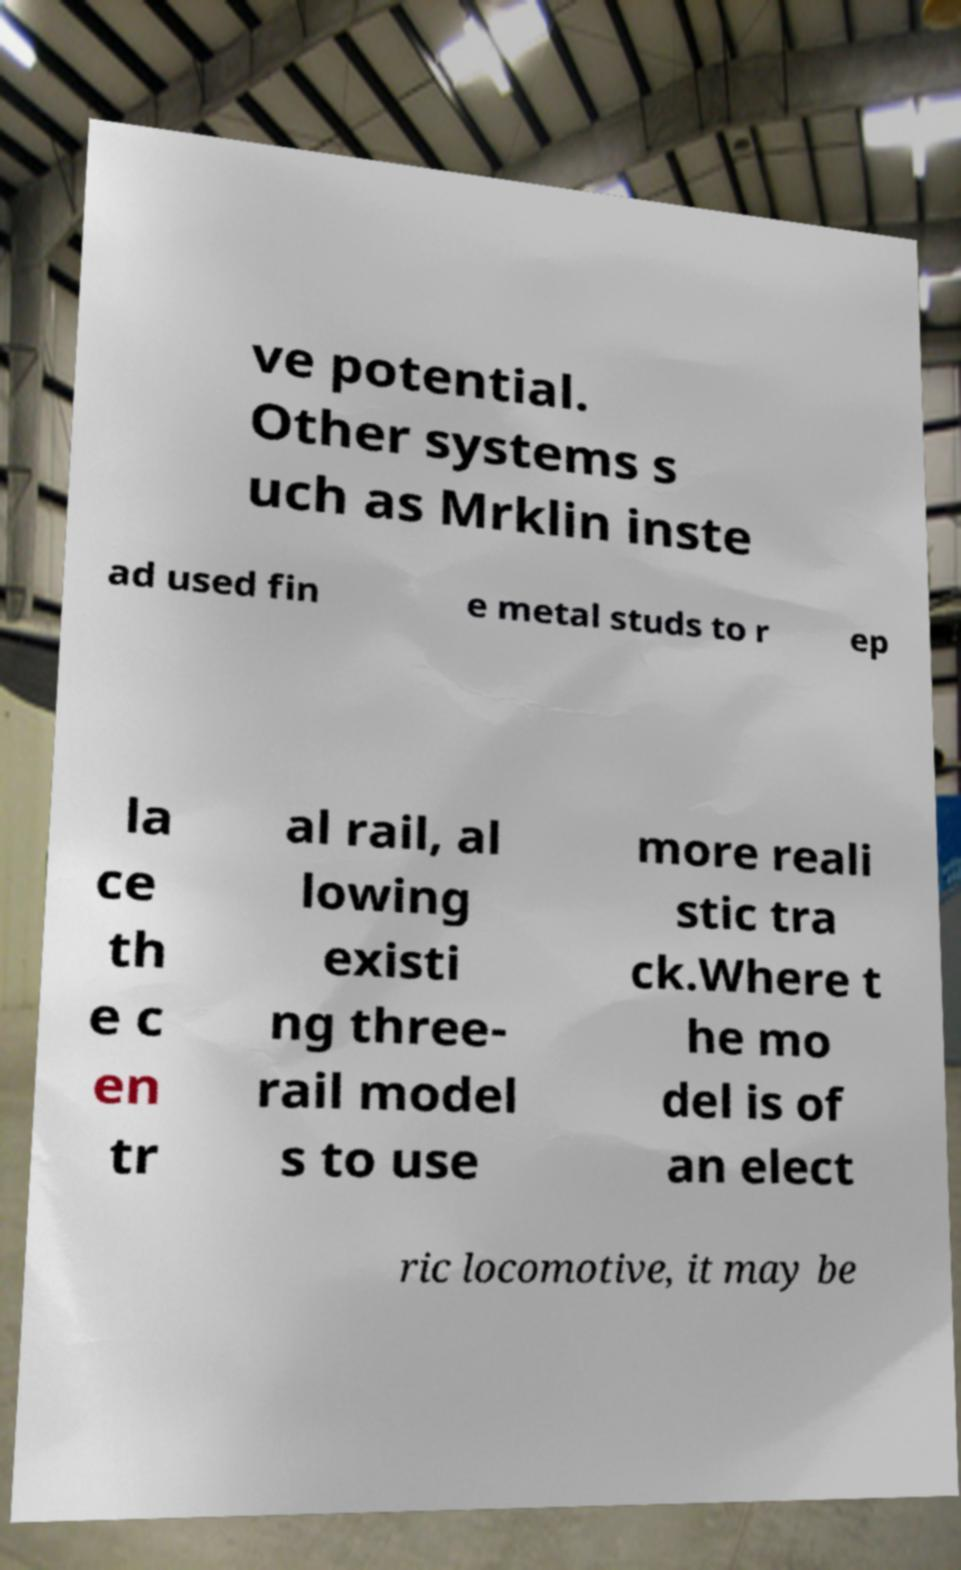Could you extract and type out the text from this image? ve potential. Other systems s uch as Mrklin inste ad used fin e metal studs to r ep la ce th e c en tr al rail, al lowing existi ng three- rail model s to use more reali stic tra ck.Where t he mo del is of an elect ric locomotive, it may be 